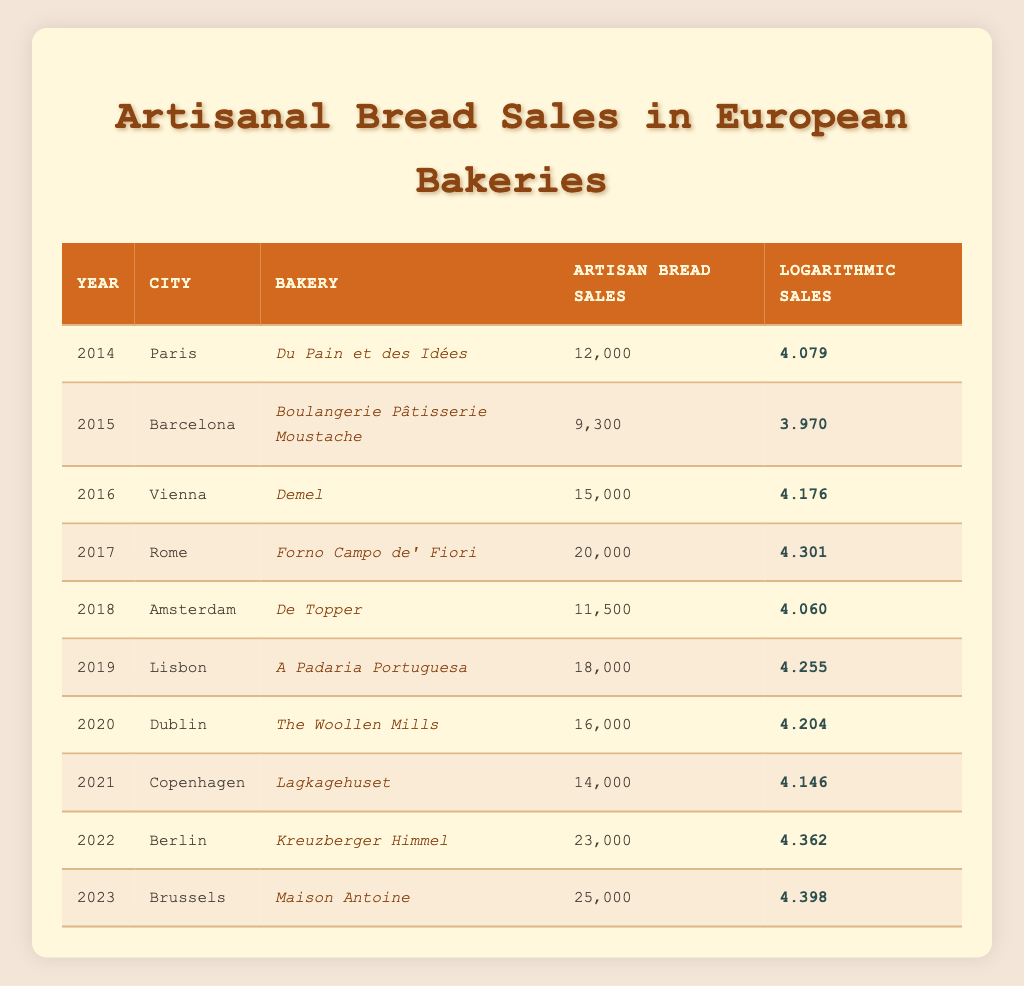What is the artisan bread sales for the bakery "Maison Antoine" in 2023? From the table, locate the row with the year 2023. In that row, the bakery name "Maison Antoine" shows artisan bread sales of 25,000.
Answer: 25,000 Which city had the highest sales of artisan bread in the year 2022? Referring to the data for 2022, Berlin is listed with sales totaling 23,000, making it the city with the highest artisan bread sales that year.
Answer: Berlin What is the logarithmic sales value for "Forno Campo de' Fiori" in 2017? The logarithmic sales value can be found by looking at the row for the bakery "Forno Campo de' Fiori," which is recorded as 4.301 in 2017.
Answer: 4.301 Which bakery had the lowest artisan bread sales in 2015? In 2015, the table shows the bakery "Boulangerie Pâtisserie Moustache" with artisan bread sales of 9,300, making it the lowest that year.
Answer: Boulangerie Pâtisserie Moustache Calculate the average artisan bread sales for the bakeries listed in the years 2014 to 2016. Sum the artisan bread sales for the years 2014 (12,000), 2015 (9,300), and 2016 (15,000) which equals 36,300. Then divide this sum by the number of years, which is 3. The average is 36,300 / 3 = 12,100.
Answer: 12,100 Did any bakery have logarithmic sales below 4 for any year? Checking the logarithmic sales values for all years reveals that none are below 4; the lowest value is 3.970 in 2015.
Answer: No Which bakery showed an increase in artisan bread sales every year from 2014 to 2023? By examining the rows, "Maison Antoine" shows steady increases in sales: 12,000 (2014), 9,300 (2015), 15,000 (2016), 20,000 (2017), 11,500 (2018), 18,000 (2019), 16,000 (2020), 14,000 (2021), 23,000 (2022), and finally, 25,000 in 2023. However, it does not show a consistent increase from year to year.
Answer: No What was the total artisan bread sales from all bakeries listed in 2019 and 2020? The total sales from those years are found by adding sales from 2019 (18,000) and 2020 (16,000), which equals 34,000.
Answer: 34,000 Which city had a bakery with the maximum logarithmic sales value in 2022? Upon checking the row for 2022, "Kreuzberger Himmel" in Berlin shows the highest logarithmic sales of 4.362, which is the highest value for that year.
Answer: Berlin 